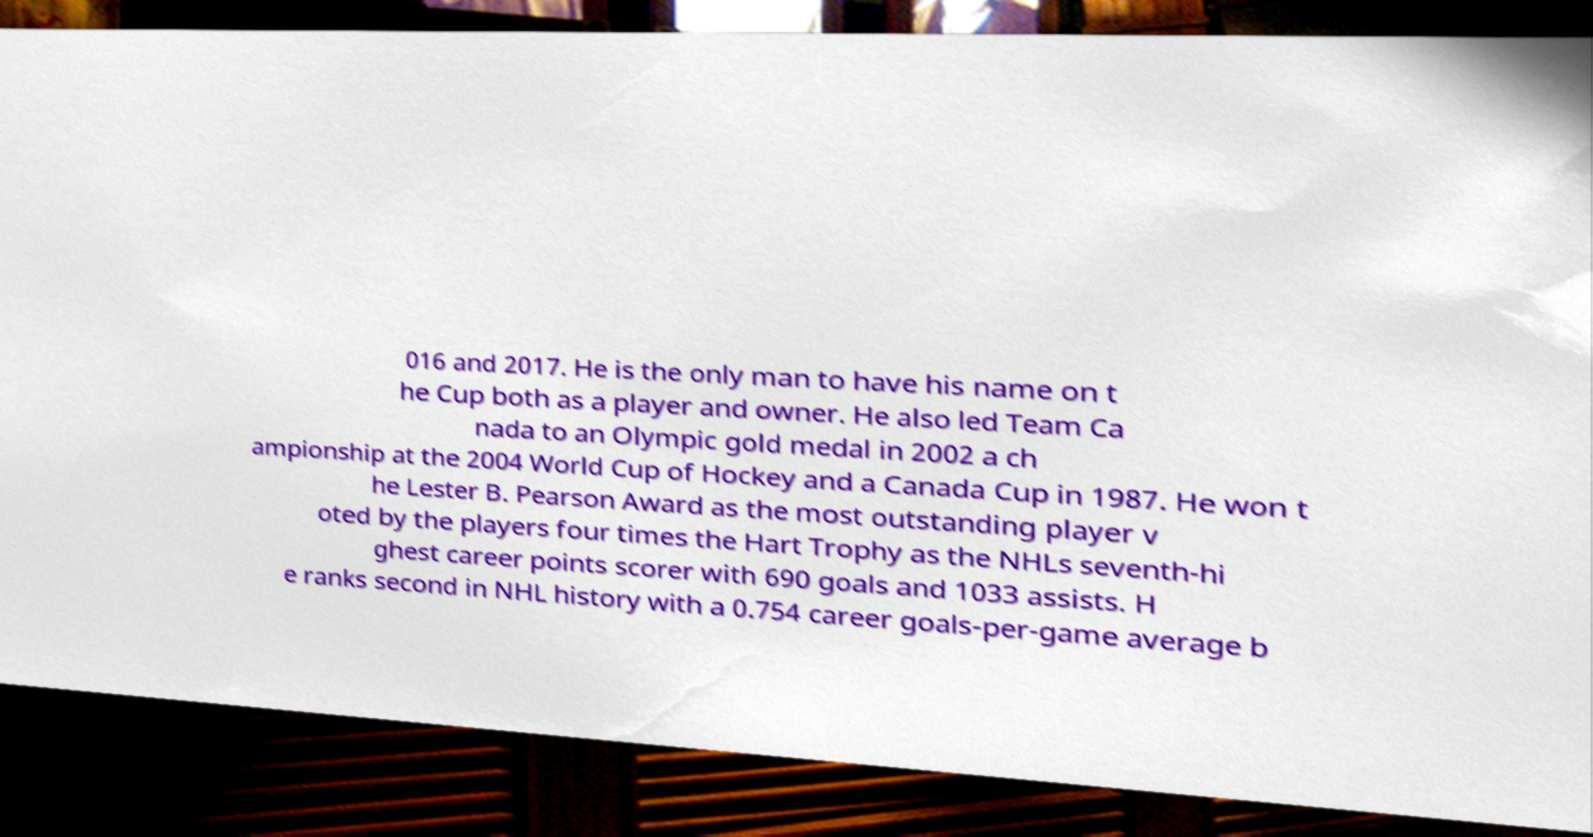Please read and relay the text visible in this image. What does it say? 016 and 2017. He is the only man to have his name on t he Cup both as a player and owner. He also led Team Ca nada to an Olympic gold medal in 2002 a ch ampionship at the 2004 World Cup of Hockey and a Canada Cup in 1987. He won t he Lester B. Pearson Award as the most outstanding player v oted by the players four times the Hart Trophy as the NHLs seventh-hi ghest career points scorer with 690 goals and 1033 assists. H e ranks second in NHL history with a 0.754 career goals-per-game average b 